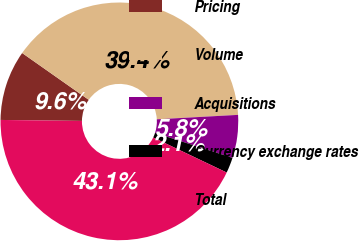<chart> <loc_0><loc_0><loc_500><loc_500><pie_chart><fcel>Pricing<fcel>Volume<fcel>Acquisitions<fcel>Currency exchange rates<fcel>Total<nl><fcel>9.56%<fcel>39.38%<fcel>5.84%<fcel>2.11%<fcel>43.11%<nl></chart> 